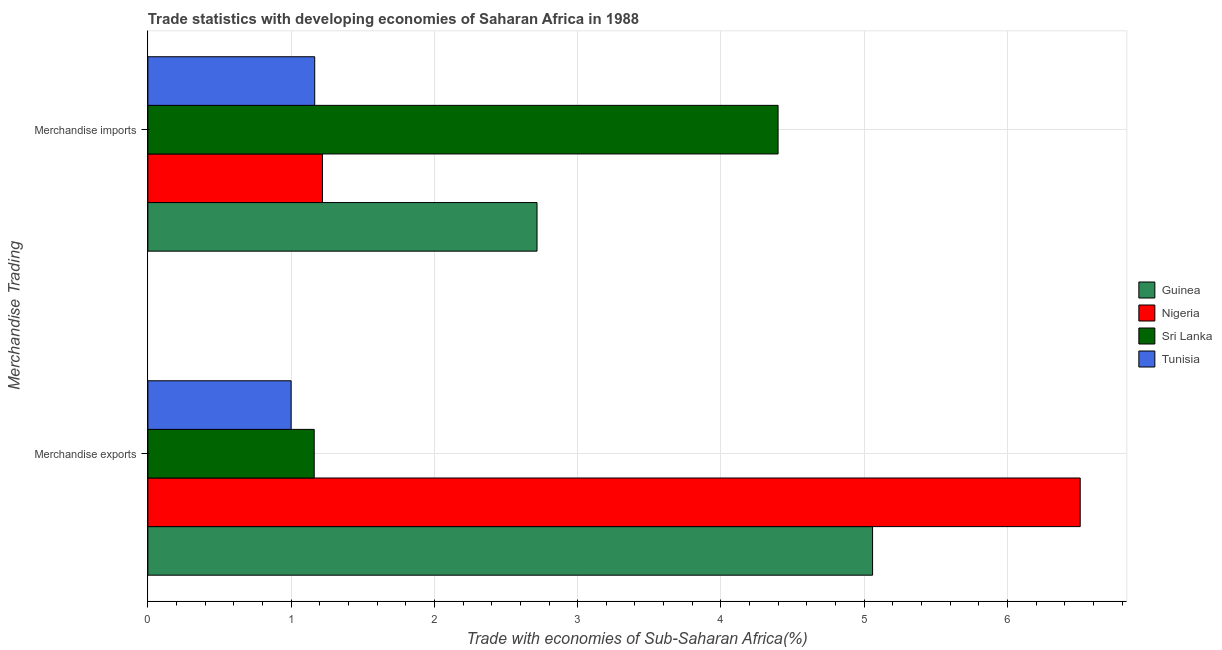How many different coloured bars are there?
Make the answer very short. 4. Are the number of bars per tick equal to the number of legend labels?
Keep it short and to the point. Yes. Are the number of bars on each tick of the Y-axis equal?
Offer a terse response. Yes. How many bars are there on the 1st tick from the top?
Ensure brevity in your answer.  4. How many bars are there on the 1st tick from the bottom?
Your answer should be compact. 4. What is the merchandise imports in Tunisia?
Your answer should be very brief. 1.16. Across all countries, what is the maximum merchandise exports?
Ensure brevity in your answer.  6.51. Across all countries, what is the minimum merchandise exports?
Keep it short and to the point. 1. In which country was the merchandise exports maximum?
Offer a very short reply. Nigeria. In which country was the merchandise imports minimum?
Your answer should be very brief. Tunisia. What is the total merchandise exports in the graph?
Provide a succinct answer. 13.73. What is the difference between the merchandise imports in Tunisia and that in Nigeria?
Your response must be concise. -0.05. What is the difference between the merchandise imports in Sri Lanka and the merchandise exports in Guinea?
Your answer should be compact. -0.66. What is the average merchandise exports per country?
Provide a succinct answer. 3.43. What is the difference between the merchandise exports and merchandise imports in Guinea?
Ensure brevity in your answer.  2.34. In how many countries, is the merchandise imports greater than 1.4 %?
Your response must be concise. 2. What is the ratio of the merchandise imports in Tunisia to that in Sri Lanka?
Offer a terse response. 0.26. Is the merchandise imports in Tunisia less than that in Sri Lanka?
Make the answer very short. Yes. In how many countries, is the merchandise imports greater than the average merchandise imports taken over all countries?
Your answer should be compact. 2. What does the 1st bar from the top in Merchandise imports represents?
Your answer should be compact. Tunisia. What does the 3rd bar from the bottom in Merchandise imports represents?
Provide a succinct answer. Sri Lanka. How many countries are there in the graph?
Make the answer very short. 4. What is the difference between two consecutive major ticks on the X-axis?
Offer a terse response. 1. Are the values on the major ticks of X-axis written in scientific E-notation?
Your answer should be very brief. No. What is the title of the graph?
Ensure brevity in your answer.  Trade statistics with developing economies of Saharan Africa in 1988. Does "Solomon Islands" appear as one of the legend labels in the graph?
Make the answer very short. No. What is the label or title of the X-axis?
Offer a very short reply. Trade with economies of Sub-Saharan Africa(%). What is the label or title of the Y-axis?
Your response must be concise. Merchandise Trading. What is the Trade with economies of Sub-Saharan Africa(%) in Guinea in Merchandise exports?
Offer a terse response. 5.06. What is the Trade with economies of Sub-Saharan Africa(%) of Nigeria in Merchandise exports?
Keep it short and to the point. 6.51. What is the Trade with economies of Sub-Saharan Africa(%) of Sri Lanka in Merchandise exports?
Offer a terse response. 1.16. What is the Trade with economies of Sub-Saharan Africa(%) of Tunisia in Merchandise exports?
Make the answer very short. 1. What is the Trade with economies of Sub-Saharan Africa(%) of Guinea in Merchandise imports?
Your response must be concise. 2.72. What is the Trade with economies of Sub-Saharan Africa(%) in Nigeria in Merchandise imports?
Give a very brief answer. 1.22. What is the Trade with economies of Sub-Saharan Africa(%) of Sri Lanka in Merchandise imports?
Keep it short and to the point. 4.4. What is the Trade with economies of Sub-Saharan Africa(%) in Tunisia in Merchandise imports?
Keep it short and to the point. 1.16. Across all Merchandise Trading, what is the maximum Trade with economies of Sub-Saharan Africa(%) of Guinea?
Your answer should be compact. 5.06. Across all Merchandise Trading, what is the maximum Trade with economies of Sub-Saharan Africa(%) of Nigeria?
Make the answer very short. 6.51. Across all Merchandise Trading, what is the maximum Trade with economies of Sub-Saharan Africa(%) in Sri Lanka?
Give a very brief answer. 4.4. Across all Merchandise Trading, what is the maximum Trade with economies of Sub-Saharan Africa(%) in Tunisia?
Offer a very short reply. 1.16. Across all Merchandise Trading, what is the minimum Trade with economies of Sub-Saharan Africa(%) of Guinea?
Ensure brevity in your answer.  2.72. Across all Merchandise Trading, what is the minimum Trade with economies of Sub-Saharan Africa(%) of Nigeria?
Ensure brevity in your answer.  1.22. Across all Merchandise Trading, what is the minimum Trade with economies of Sub-Saharan Africa(%) in Sri Lanka?
Provide a succinct answer. 1.16. Across all Merchandise Trading, what is the minimum Trade with economies of Sub-Saharan Africa(%) of Tunisia?
Keep it short and to the point. 1. What is the total Trade with economies of Sub-Saharan Africa(%) of Guinea in the graph?
Keep it short and to the point. 7.78. What is the total Trade with economies of Sub-Saharan Africa(%) of Nigeria in the graph?
Offer a terse response. 7.73. What is the total Trade with economies of Sub-Saharan Africa(%) in Sri Lanka in the graph?
Ensure brevity in your answer.  5.56. What is the total Trade with economies of Sub-Saharan Africa(%) in Tunisia in the graph?
Your answer should be compact. 2.16. What is the difference between the Trade with economies of Sub-Saharan Africa(%) in Guinea in Merchandise exports and that in Merchandise imports?
Ensure brevity in your answer.  2.34. What is the difference between the Trade with economies of Sub-Saharan Africa(%) in Nigeria in Merchandise exports and that in Merchandise imports?
Ensure brevity in your answer.  5.29. What is the difference between the Trade with economies of Sub-Saharan Africa(%) of Sri Lanka in Merchandise exports and that in Merchandise imports?
Offer a very short reply. -3.24. What is the difference between the Trade with economies of Sub-Saharan Africa(%) of Tunisia in Merchandise exports and that in Merchandise imports?
Give a very brief answer. -0.16. What is the difference between the Trade with economies of Sub-Saharan Africa(%) of Guinea in Merchandise exports and the Trade with economies of Sub-Saharan Africa(%) of Nigeria in Merchandise imports?
Your answer should be very brief. 3.84. What is the difference between the Trade with economies of Sub-Saharan Africa(%) in Guinea in Merchandise exports and the Trade with economies of Sub-Saharan Africa(%) in Sri Lanka in Merchandise imports?
Give a very brief answer. 0.66. What is the difference between the Trade with economies of Sub-Saharan Africa(%) of Guinea in Merchandise exports and the Trade with economies of Sub-Saharan Africa(%) of Tunisia in Merchandise imports?
Offer a very short reply. 3.89. What is the difference between the Trade with economies of Sub-Saharan Africa(%) in Nigeria in Merchandise exports and the Trade with economies of Sub-Saharan Africa(%) in Sri Lanka in Merchandise imports?
Offer a very short reply. 2.11. What is the difference between the Trade with economies of Sub-Saharan Africa(%) of Nigeria in Merchandise exports and the Trade with economies of Sub-Saharan Africa(%) of Tunisia in Merchandise imports?
Your response must be concise. 5.34. What is the difference between the Trade with economies of Sub-Saharan Africa(%) of Sri Lanka in Merchandise exports and the Trade with economies of Sub-Saharan Africa(%) of Tunisia in Merchandise imports?
Provide a short and direct response. -0. What is the average Trade with economies of Sub-Saharan Africa(%) in Guinea per Merchandise Trading?
Offer a very short reply. 3.89. What is the average Trade with economies of Sub-Saharan Africa(%) in Nigeria per Merchandise Trading?
Ensure brevity in your answer.  3.86. What is the average Trade with economies of Sub-Saharan Africa(%) in Sri Lanka per Merchandise Trading?
Provide a short and direct response. 2.78. What is the average Trade with economies of Sub-Saharan Africa(%) of Tunisia per Merchandise Trading?
Keep it short and to the point. 1.08. What is the difference between the Trade with economies of Sub-Saharan Africa(%) in Guinea and Trade with economies of Sub-Saharan Africa(%) in Nigeria in Merchandise exports?
Offer a very short reply. -1.45. What is the difference between the Trade with economies of Sub-Saharan Africa(%) in Guinea and Trade with economies of Sub-Saharan Africa(%) in Sri Lanka in Merchandise exports?
Offer a terse response. 3.9. What is the difference between the Trade with economies of Sub-Saharan Africa(%) in Guinea and Trade with economies of Sub-Saharan Africa(%) in Tunisia in Merchandise exports?
Give a very brief answer. 4.06. What is the difference between the Trade with economies of Sub-Saharan Africa(%) in Nigeria and Trade with economies of Sub-Saharan Africa(%) in Sri Lanka in Merchandise exports?
Make the answer very short. 5.35. What is the difference between the Trade with economies of Sub-Saharan Africa(%) in Nigeria and Trade with economies of Sub-Saharan Africa(%) in Tunisia in Merchandise exports?
Keep it short and to the point. 5.51. What is the difference between the Trade with economies of Sub-Saharan Africa(%) in Sri Lanka and Trade with economies of Sub-Saharan Africa(%) in Tunisia in Merchandise exports?
Offer a very short reply. 0.16. What is the difference between the Trade with economies of Sub-Saharan Africa(%) in Guinea and Trade with economies of Sub-Saharan Africa(%) in Nigeria in Merchandise imports?
Ensure brevity in your answer.  1.5. What is the difference between the Trade with economies of Sub-Saharan Africa(%) of Guinea and Trade with economies of Sub-Saharan Africa(%) of Sri Lanka in Merchandise imports?
Keep it short and to the point. -1.68. What is the difference between the Trade with economies of Sub-Saharan Africa(%) in Guinea and Trade with economies of Sub-Saharan Africa(%) in Tunisia in Merchandise imports?
Provide a succinct answer. 1.55. What is the difference between the Trade with economies of Sub-Saharan Africa(%) in Nigeria and Trade with economies of Sub-Saharan Africa(%) in Sri Lanka in Merchandise imports?
Give a very brief answer. -3.18. What is the difference between the Trade with economies of Sub-Saharan Africa(%) of Nigeria and Trade with economies of Sub-Saharan Africa(%) of Tunisia in Merchandise imports?
Your response must be concise. 0.05. What is the difference between the Trade with economies of Sub-Saharan Africa(%) of Sri Lanka and Trade with economies of Sub-Saharan Africa(%) of Tunisia in Merchandise imports?
Your answer should be very brief. 3.23. What is the ratio of the Trade with economies of Sub-Saharan Africa(%) in Guinea in Merchandise exports to that in Merchandise imports?
Provide a short and direct response. 1.86. What is the ratio of the Trade with economies of Sub-Saharan Africa(%) in Nigeria in Merchandise exports to that in Merchandise imports?
Your answer should be compact. 5.34. What is the ratio of the Trade with economies of Sub-Saharan Africa(%) in Sri Lanka in Merchandise exports to that in Merchandise imports?
Offer a very short reply. 0.26. What is the ratio of the Trade with economies of Sub-Saharan Africa(%) in Tunisia in Merchandise exports to that in Merchandise imports?
Make the answer very short. 0.86. What is the difference between the highest and the second highest Trade with economies of Sub-Saharan Africa(%) in Guinea?
Your answer should be very brief. 2.34. What is the difference between the highest and the second highest Trade with economies of Sub-Saharan Africa(%) in Nigeria?
Provide a short and direct response. 5.29. What is the difference between the highest and the second highest Trade with economies of Sub-Saharan Africa(%) of Sri Lanka?
Keep it short and to the point. 3.24. What is the difference between the highest and the second highest Trade with economies of Sub-Saharan Africa(%) of Tunisia?
Make the answer very short. 0.16. What is the difference between the highest and the lowest Trade with economies of Sub-Saharan Africa(%) of Guinea?
Offer a very short reply. 2.34. What is the difference between the highest and the lowest Trade with economies of Sub-Saharan Africa(%) of Nigeria?
Provide a succinct answer. 5.29. What is the difference between the highest and the lowest Trade with economies of Sub-Saharan Africa(%) of Sri Lanka?
Keep it short and to the point. 3.24. What is the difference between the highest and the lowest Trade with economies of Sub-Saharan Africa(%) of Tunisia?
Give a very brief answer. 0.16. 